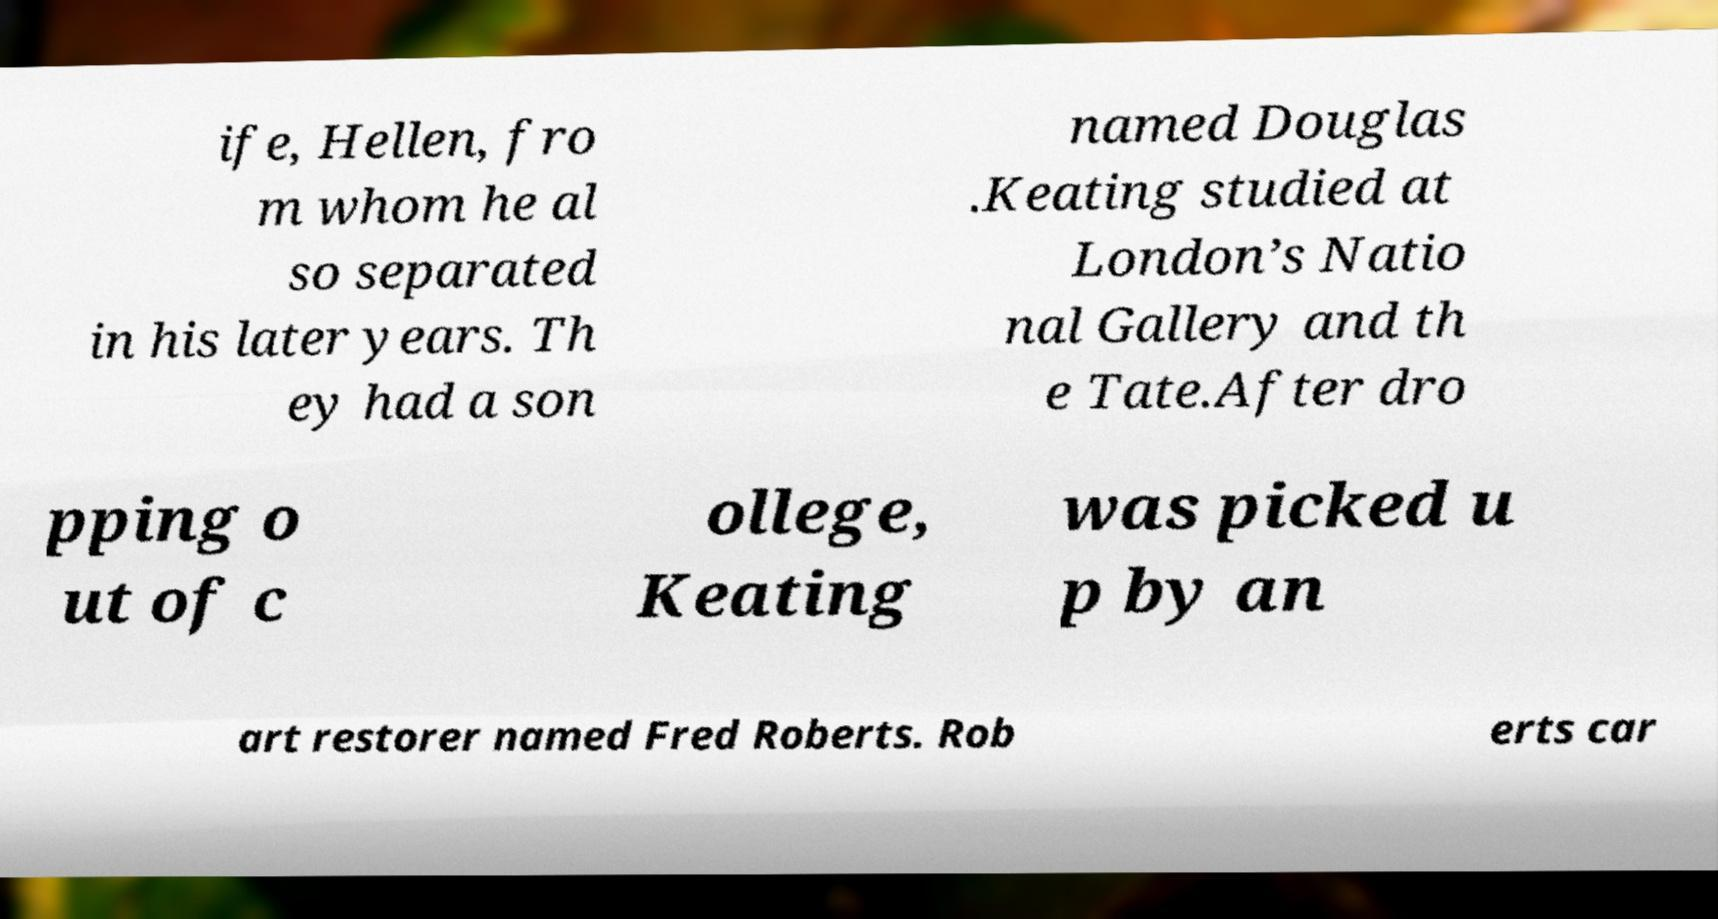Please identify and transcribe the text found in this image. ife, Hellen, fro m whom he al so separated in his later years. Th ey had a son named Douglas .Keating studied at London’s Natio nal Gallery and th e Tate.After dro pping o ut of c ollege, Keating was picked u p by an art restorer named Fred Roberts. Rob erts car 